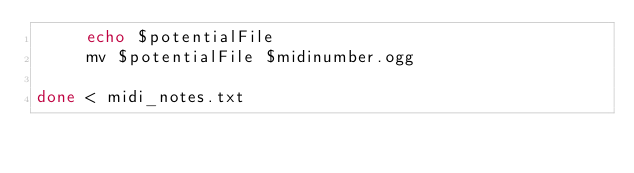<code> <loc_0><loc_0><loc_500><loc_500><_Bash_>	 echo $potentialFile
	 mv $potentialFile $midinumber.ogg
     
done < midi_notes.txt
</code> 